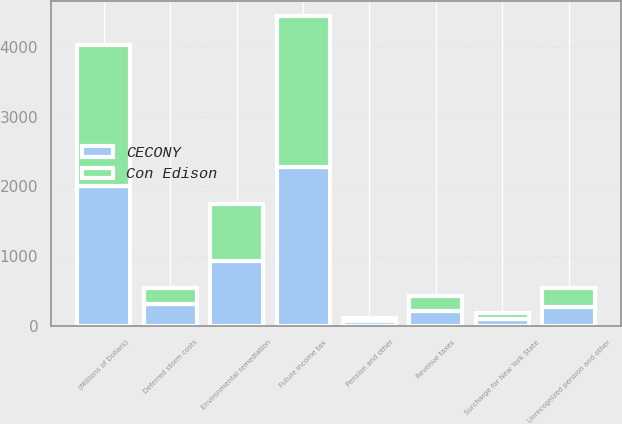Convert chart. <chart><loc_0><loc_0><loc_500><loc_500><stacked_bar_chart><ecel><fcel>(Millions of Dollars)<fcel>Unrecognized pension and other<fcel>Future income tax<fcel>Environmental remediation<fcel>Deferred storm costs<fcel>Revenue taxes<fcel>Surcharge for New York State<fcel>Pension and other<nl><fcel>CECONY<fcel>2014<fcel>271.5<fcel>2273<fcel>925<fcel>319<fcel>219<fcel>99<fcel>66<nl><fcel>Con Edison<fcel>2014<fcel>271.5<fcel>2166<fcel>820<fcel>224<fcel>208<fcel>92<fcel>42<nl></chart> 